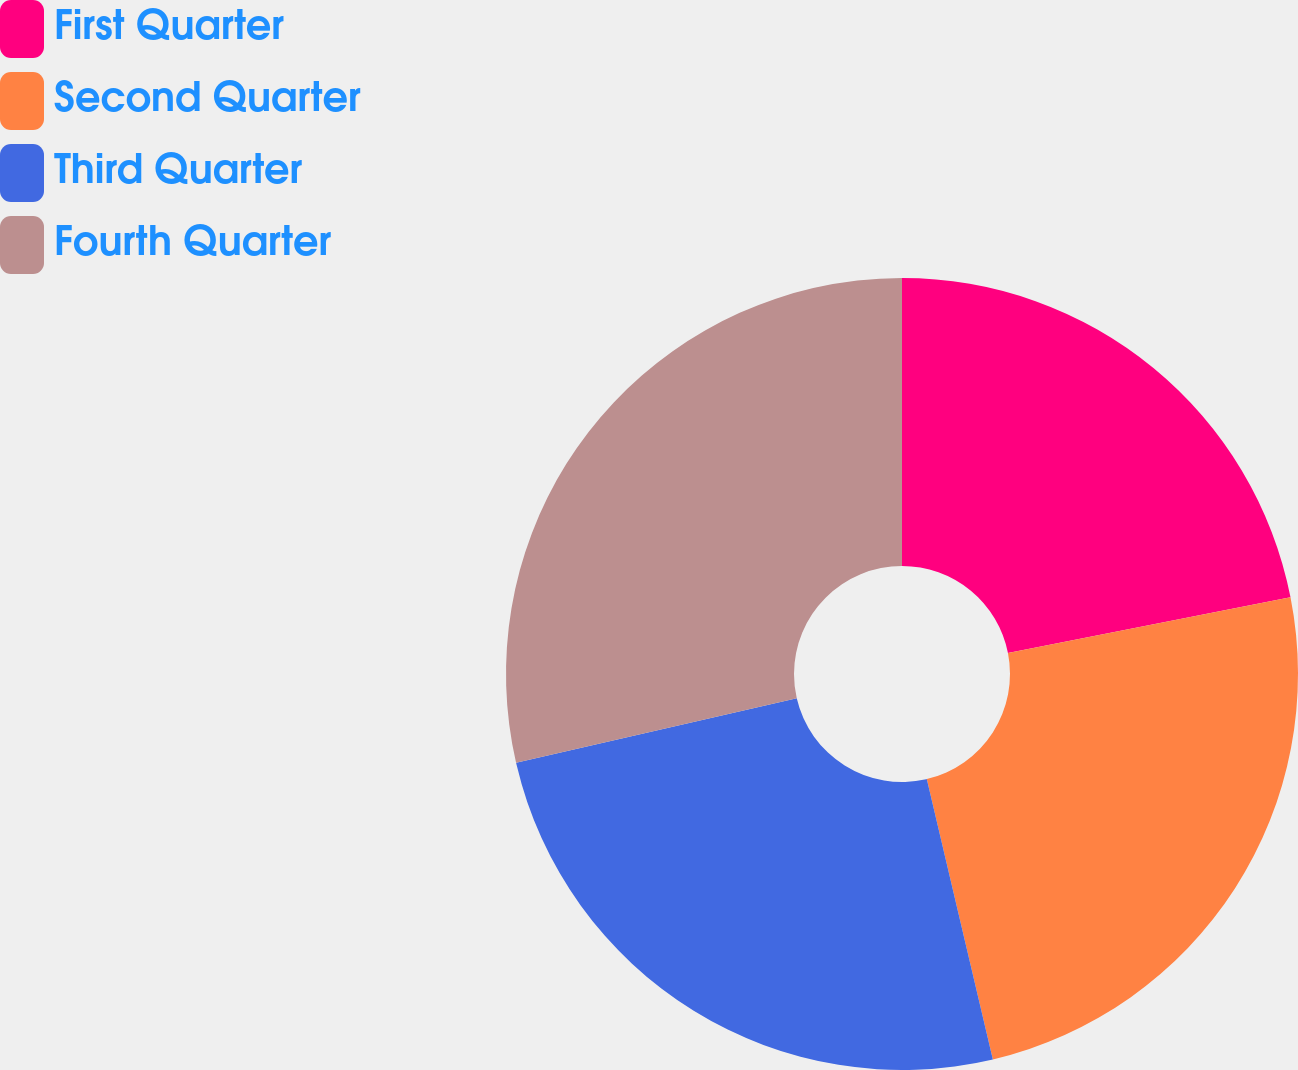Convert chart to OTSL. <chart><loc_0><loc_0><loc_500><loc_500><pie_chart><fcel>First Quarter<fcel>Second Quarter<fcel>Third Quarter<fcel>Fourth Quarter<nl><fcel>21.9%<fcel>24.42%<fcel>25.09%<fcel>28.6%<nl></chart> 